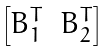<formula> <loc_0><loc_0><loc_500><loc_500>\begin{bmatrix} B _ { 1 } ^ { T } & B _ { 2 } ^ { T } \end{bmatrix}</formula> 